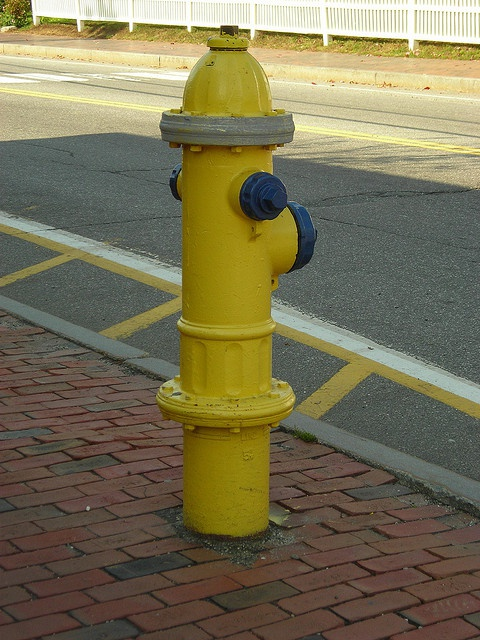Describe the objects in this image and their specific colors. I can see a fire hydrant in darkgreen, olive, and gray tones in this image. 